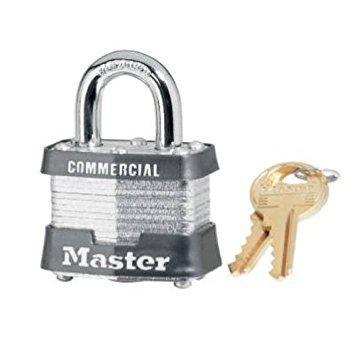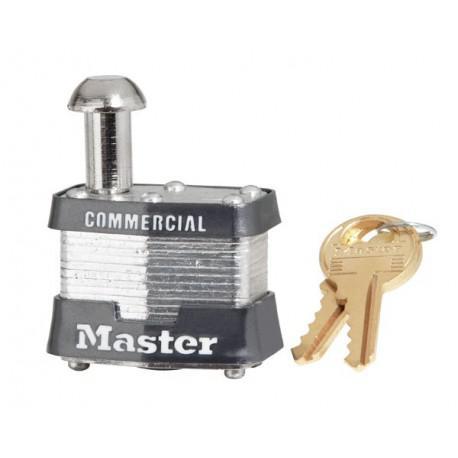The first image is the image on the left, the second image is the image on the right. For the images shown, is this caption "Each image includes just one lock, and all locks have red bodies." true? Answer yes or no. No. 